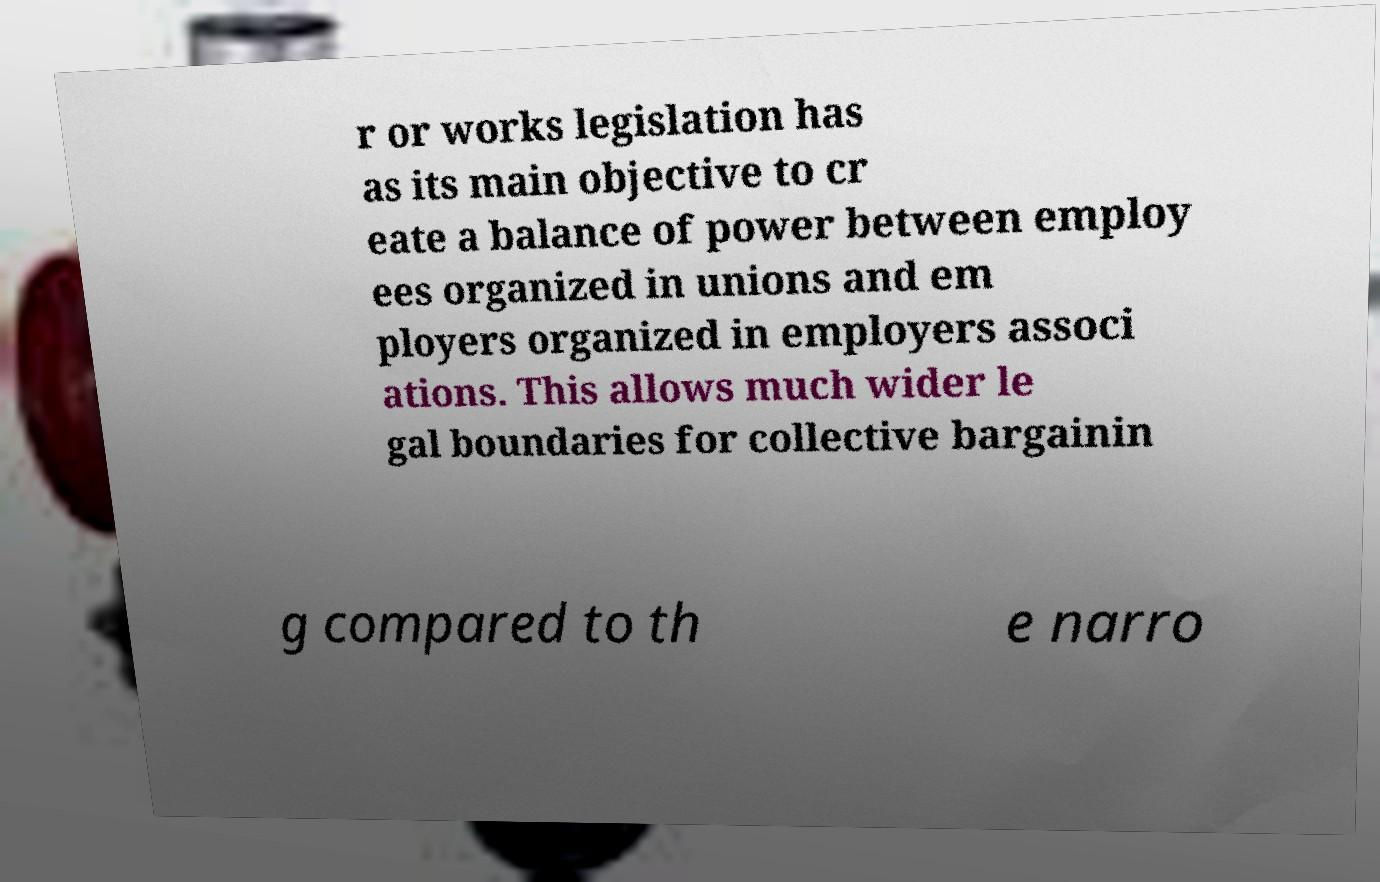There's text embedded in this image that I need extracted. Can you transcribe it verbatim? r or works legislation has as its main objective to cr eate a balance of power between employ ees organized in unions and em ployers organized in employers associ ations. This allows much wider le gal boundaries for collective bargainin g compared to th e narro 